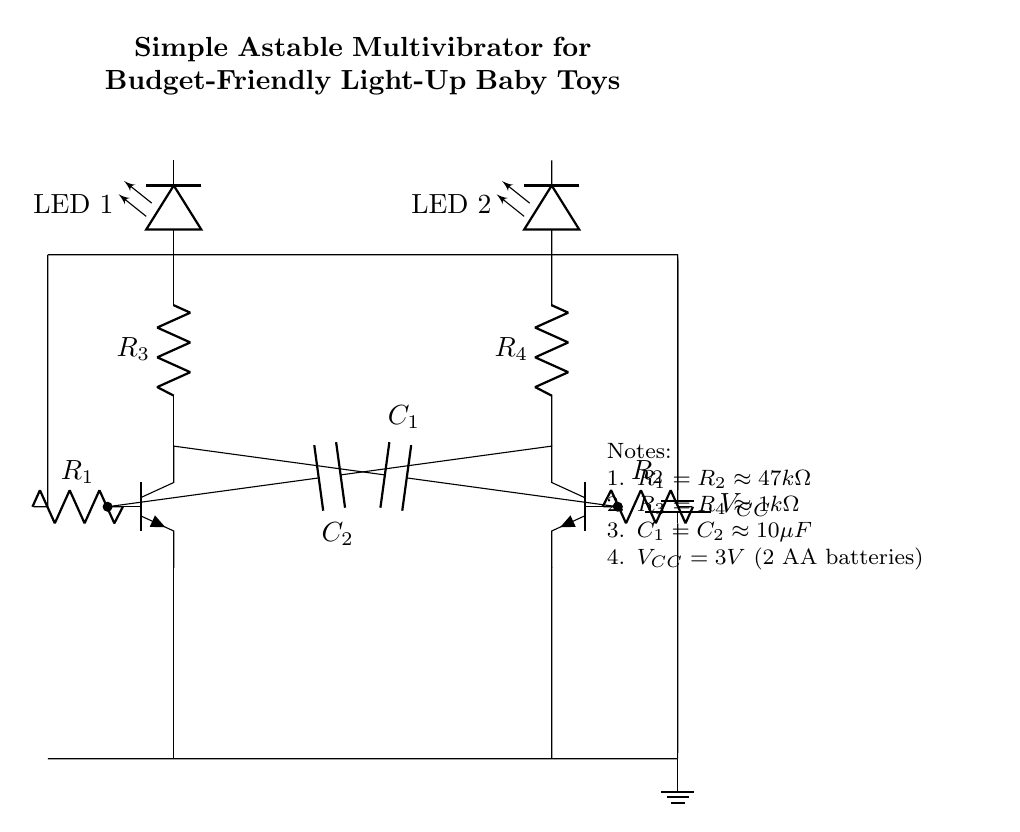What type of circuit is depicted? The circuit depicted is an astable multivibrator, which continuously oscillates between its two unstable states, creating a square wave output signal.
Answer: Astable multivibrator What do the resistors R1 and R2 do? Resistors R1 and R2 serve as base resistors that control the timing and frequency of the oscillation in the circuit. They help determine how long the transistors remain on or off, affecting the blinking rate of the LEDs.
Answer: Control timing What is the function of capacitors C1 and C2? Capacitors C1 and C2 are used to set the timing intervals for the astable multivibrator operation. They charge and discharge, causing the transistors to switch, leading to the oscillation and blinking of the LEDs.
Answer: Timing intervals How many LEDs are present in the circuit? There are two LEDs in the circuit, which are placed at the output of the transistors to indicate the oscillation visually by lighting up alternately.
Answer: Two What is the power supply voltage in this circuit? The power supply voltage for this circuit is 3 volts, which is provided by two AA batteries connected in series. This voltage is essential to power the transistors and the LEDs.
Answer: Three volts What approximate values are used for resistors R3 and R4? The approximate values for resistors R3 and R4 are 1k ohm, which sets the current limitations for the LEDs connected at the outputs. This helps protect the LEDs from excess current.
Answer: One thousand ohms 